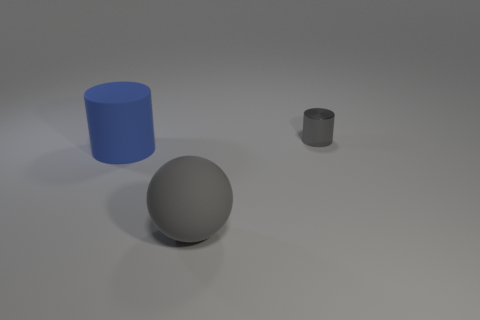Add 3 gray matte spheres. How many objects exist? 6 Subtract all spheres. How many objects are left? 2 Add 1 gray objects. How many gray objects are left? 3 Add 1 balls. How many balls exist? 2 Subtract 1 gray cylinders. How many objects are left? 2 Subtract all gray metal cylinders. Subtract all gray rubber balls. How many objects are left? 1 